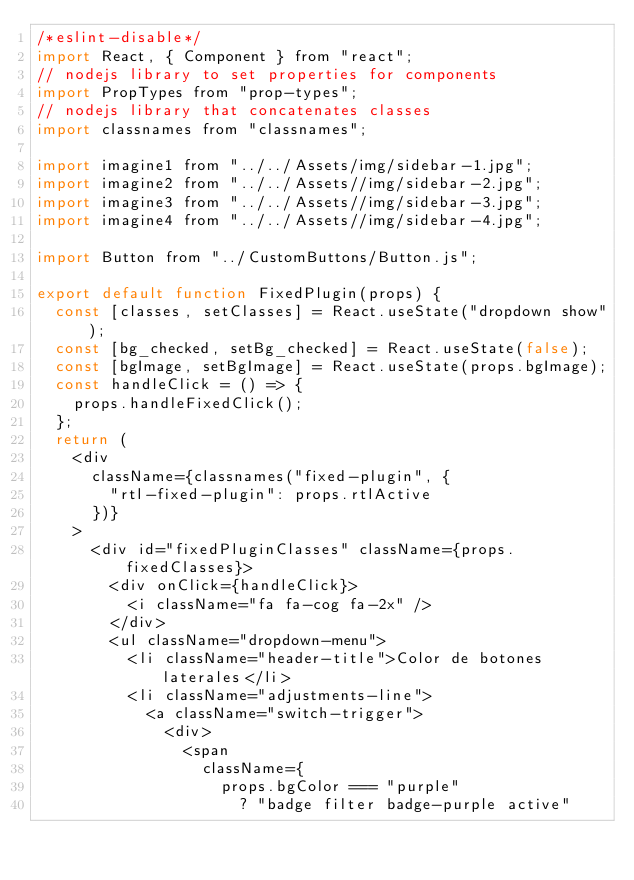<code> <loc_0><loc_0><loc_500><loc_500><_JavaScript_>/*eslint-disable*/
import React, { Component } from "react";
// nodejs library to set properties for components
import PropTypes from "prop-types";
// nodejs library that concatenates classes
import classnames from "classnames";

import imagine1 from "../../Assets/img/sidebar-1.jpg";
import imagine2 from "../../Assets//img/sidebar-2.jpg";
import imagine3 from "../../Assets//img/sidebar-3.jpg";
import imagine4 from "../../Assets//img/sidebar-4.jpg";

import Button from "../CustomButtons/Button.js";

export default function FixedPlugin(props) {
  const [classes, setClasses] = React.useState("dropdown show");
  const [bg_checked, setBg_checked] = React.useState(false);
  const [bgImage, setBgImage] = React.useState(props.bgImage);
  const handleClick = () => {
    props.handleFixedClick();
  };
  return (
    <div
      className={classnames("fixed-plugin", {
        "rtl-fixed-plugin": props.rtlActive
      })}
    >
      <div id="fixedPluginClasses" className={props.fixedClasses}>
        <div onClick={handleClick}>
          <i className="fa fa-cog fa-2x" />
        </div>
        <ul className="dropdown-menu">
          <li className="header-title">Color de botones laterales</li>
          <li className="adjustments-line">
            <a className="switch-trigger">
              <div>
                <span
                  className={
                    props.bgColor === "purple"
                      ? "badge filter badge-purple active"</code> 